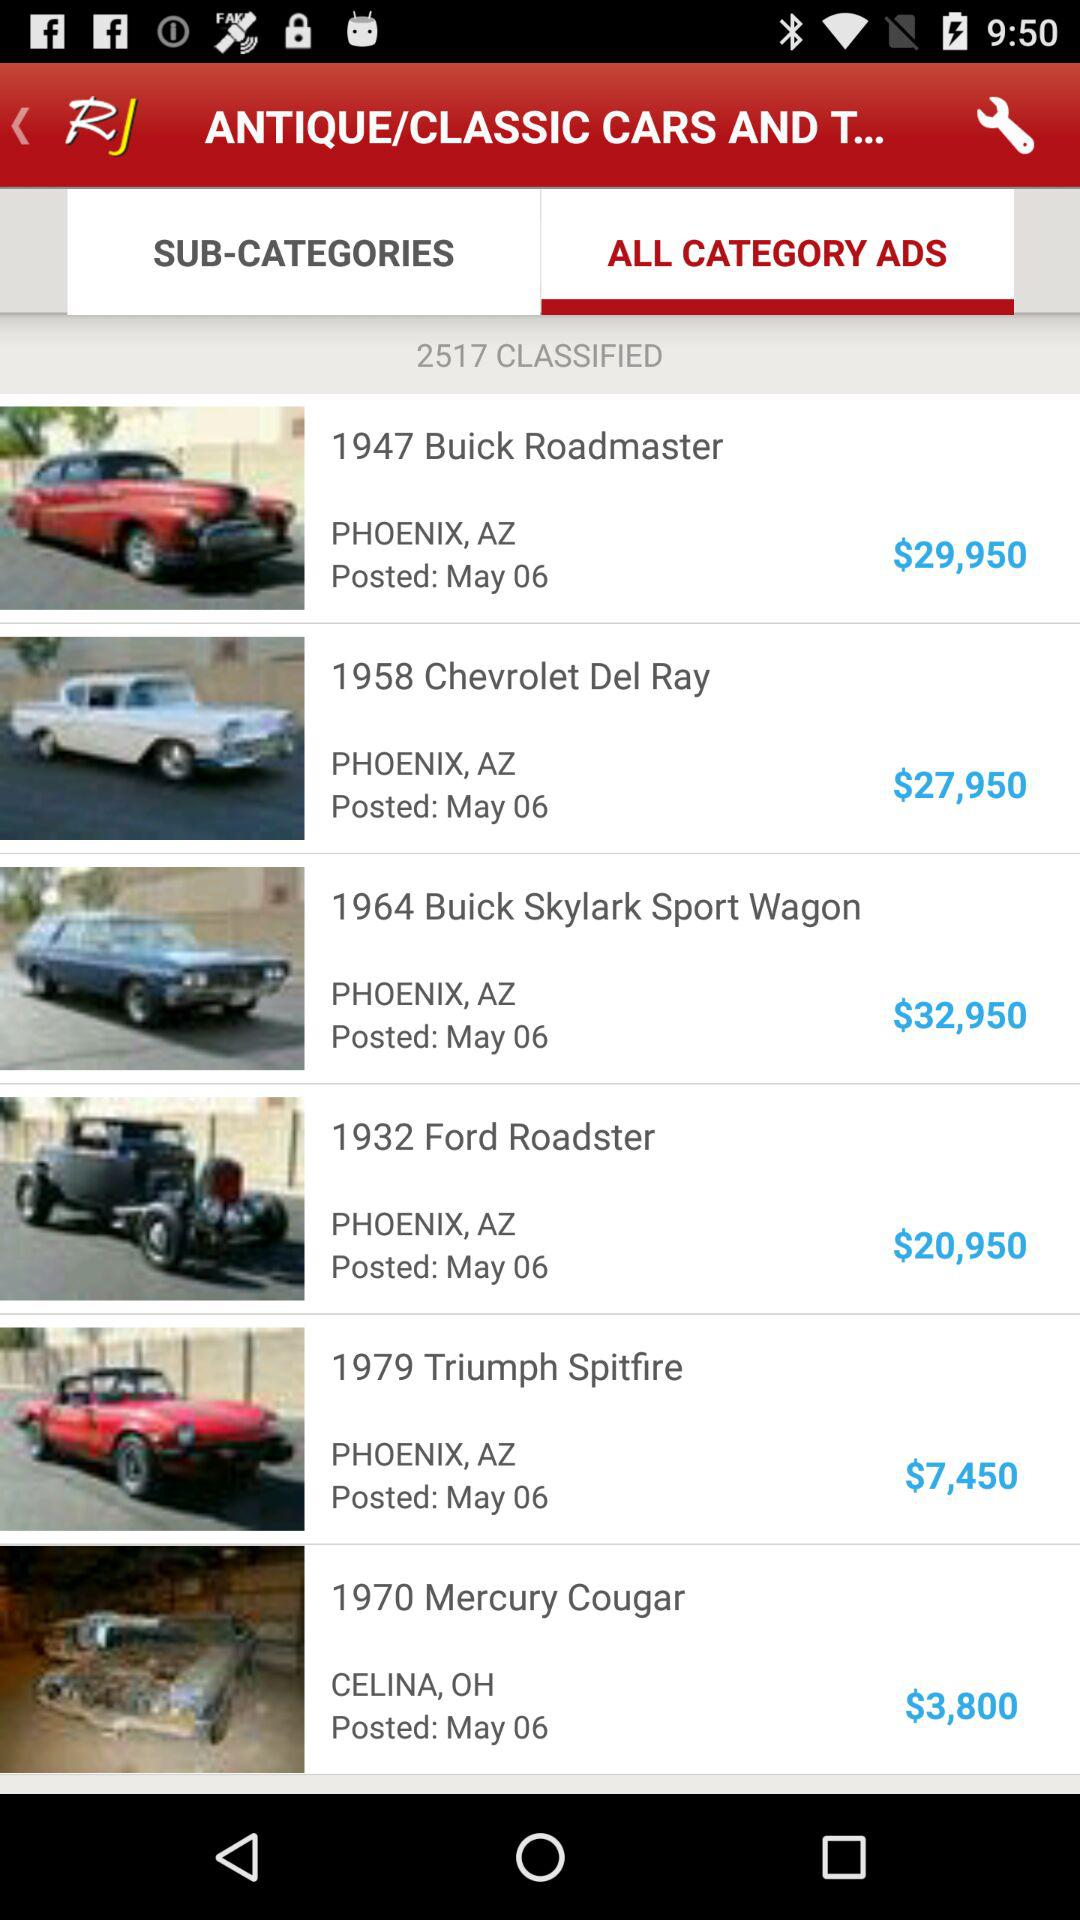What is the model year of the "Skylark Sport Wagon"? The model year is 1964. 